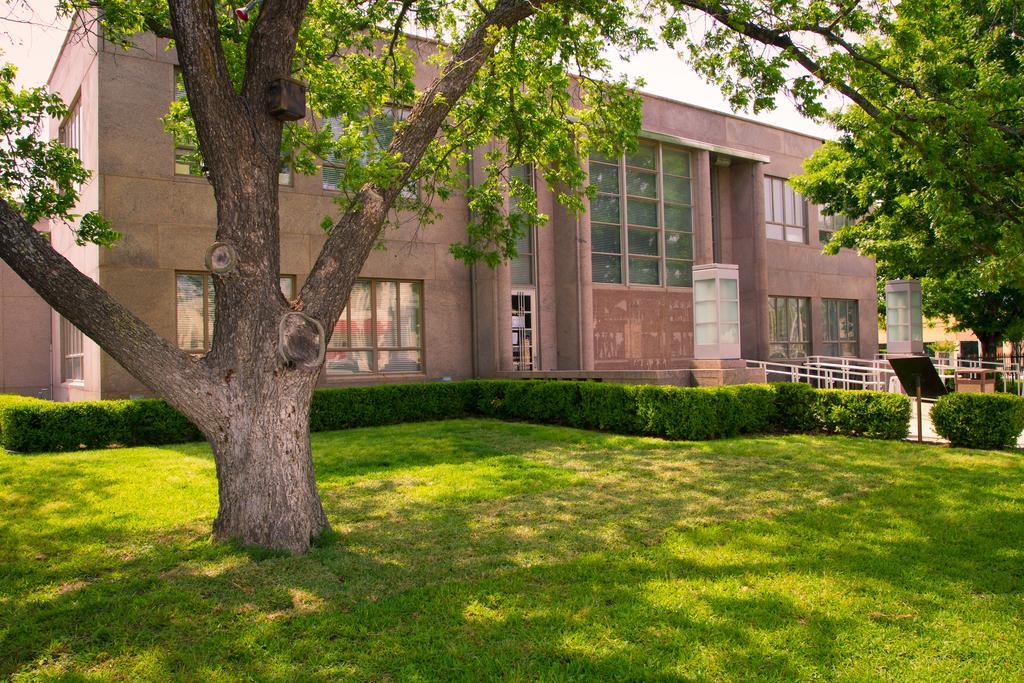In one or two sentences, can you explain what this image depicts? In the picture I can see trees, plants, the grass, a building, fence and some other objects. In the background I can see the sky. 